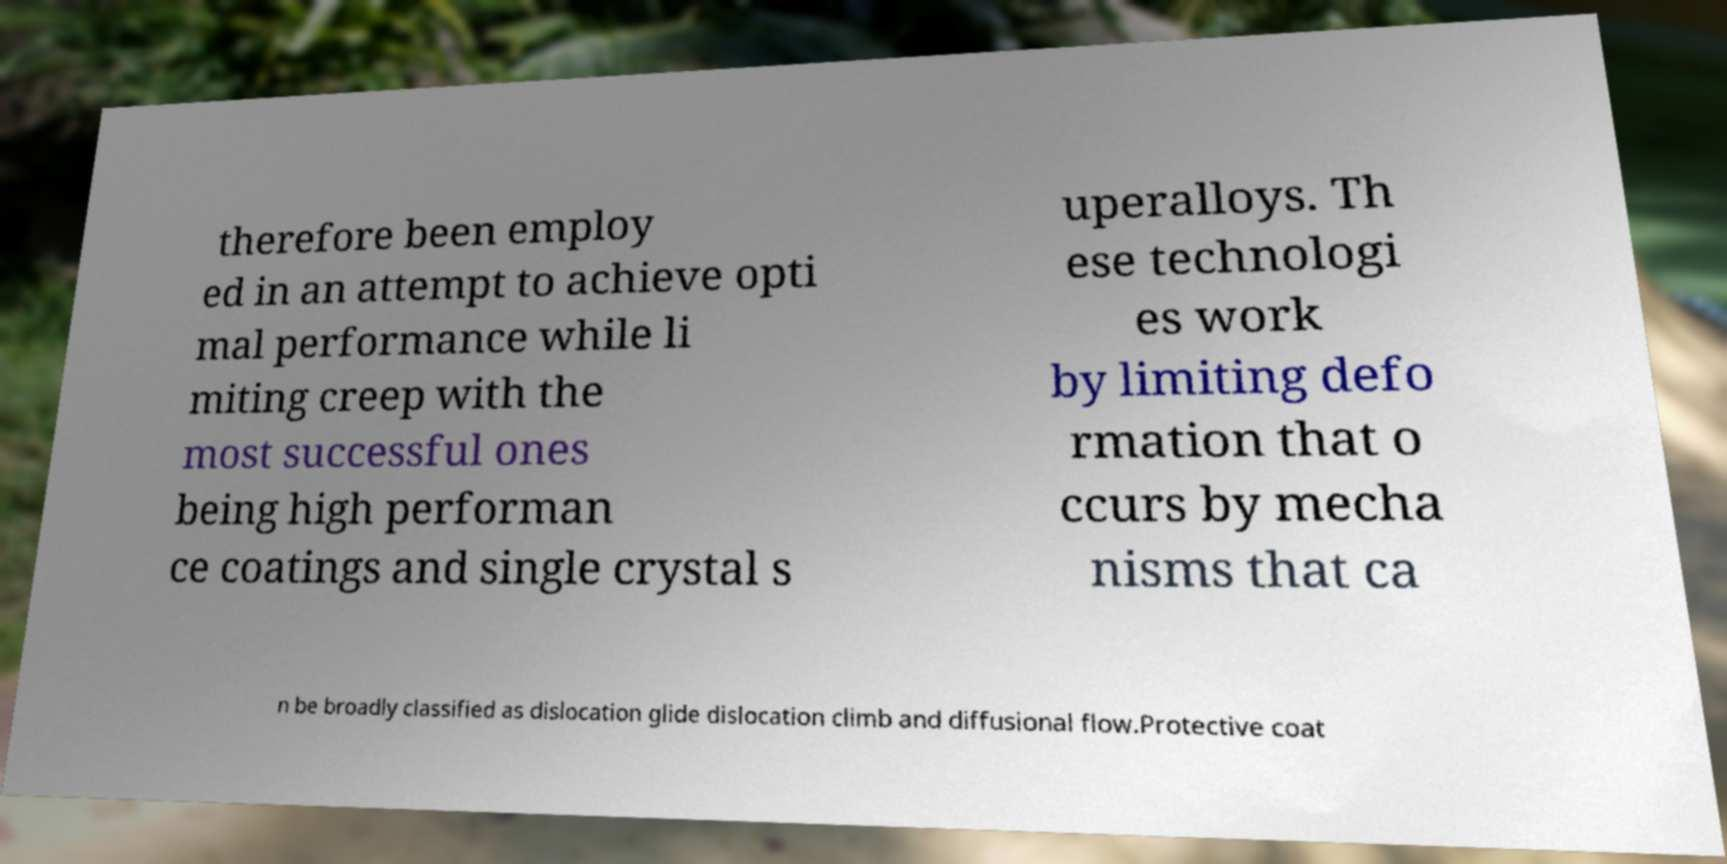Please read and relay the text visible in this image. What does it say? therefore been employ ed in an attempt to achieve opti mal performance while li miting creep with the most successful ones being high performan ce coatings and single crystal s uperalloys. Th ese technologi es work by limiting defo rmation that o ccurs by mecha nisms that ca n be broadly classified as dislocation glide dislocation climb and diffusional flow.Protective coat 